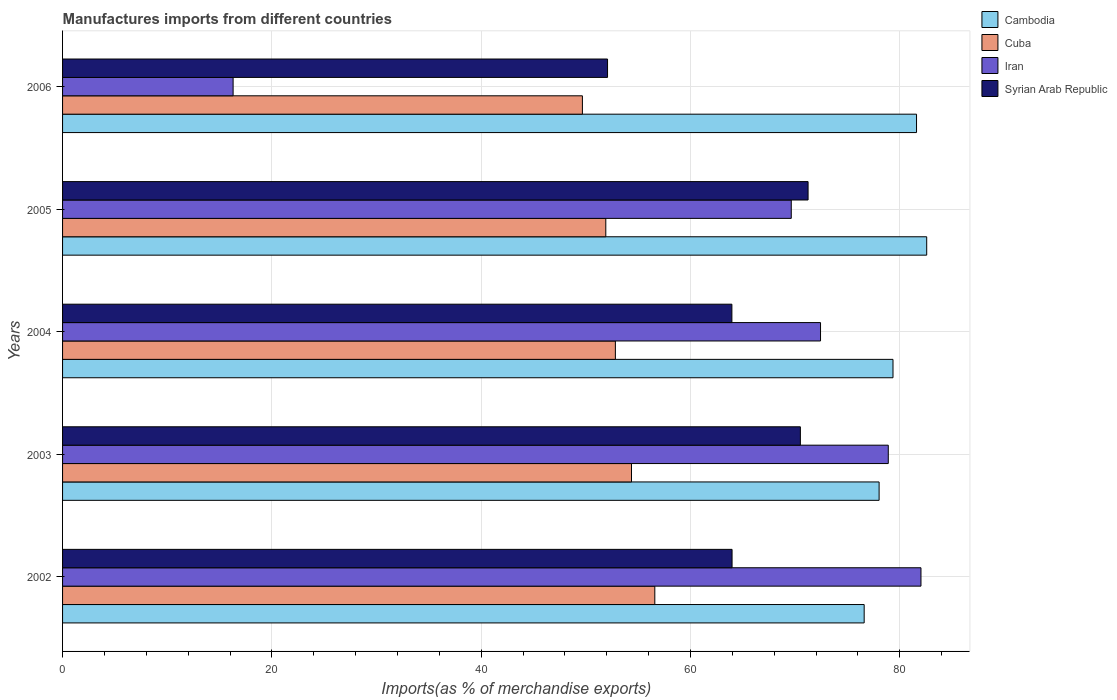How many groups of bars are there?
Offer a terse response. 5. Are the number of bars per tick equal to the number of legend labels?
Provide a short and direct response. Yes. How many bars are there on the 2nd tick from the top?
Offer a terse response. 4. How many bars are there on the 3rd tick from the bottom?
Offer a terse response. 4. What is the label of the 4th group of bars from the top?
Give a very brief answer. 2003. What is the percentage of imports to different countries in Cambodia in 2006?
Your response must be concise. 81.6. Across all years, what is the maximum percentage of imports to different countries in Cambodia?
Offer a terse response. 82.57. Across all years, what is the minimum percentage of imports to different countries in Cambodia?
Your answer should be very brief. 76.59. What is the total percentage of imports to different countries in Syrian Arab Republic in the graph?
Give a very brief answer. 321.72. What is the difference between the percentage of imports to different countries in Cuba in 2003 and that in 2004?
Your answer should be very brief. 1.54. What is the difference between the percentage of imports to different countries in Cuba in 2006 and the percentage of imports to different countries in Iran in 2005?
Provide a short and direct response. -19.96. What is the average percentage of imports to different countries in Syrian Arab Republic per year?
Your answer should be very brief. 64.34. In the year 2004, what is the difference between the percentage of imports to different countries in Syrian Arab Republic and percentage of imports to different countries in Cuba?
Provide a succinct answer. 11.13. In how many years, is the percentage of imports to different countries in Cuba greater than 52 %?
Keep it short and to the point. 3. What is the ratio of the percentage of imports to different countries in Iran in 2002 to that in 2004?
Provide a short and direct response. 1.13. What is the difference between the highest and the second highest percentage of imports to different countries in Cambodia?
Offer a very short reply. 0.97. What is the difference between the highest and the lowest percentage of imports to different countries in Iran?
Ensure brevity in your answer.  65.72. In how many years, is the percentage of imports to different countries in Syrian Arab Republic greater than the average percentage of imports to different countries in Syrian Arab Republic taken over all years?
Your response must be concise. 2. Is the sum of the percentage of imports to different countries in Cambodia in 2005 and 2006 greater than the maximum percentage of imports to different countries in Iran across all years?
Offer a very short reply. Yes. Is it the case that in every year, the sum of the percentage of imports to different countries in Iran and percentage of imports to different countries in Syrian Arab Republic is greater than the sum of percentage of imports to different countries in Cuba and percentage of imports to different countries in Cambodia?
Provide a short and direct response. No. What does the 4th bar from the top in 2006 represents?
Your response must be concise. Cambodia. What does the 4th bar from the bottom in 2003 represents?
Offer a very short reply. Syrian Arab Republic. Is it the case that in every year, the sum of the percentage of imports to different countries in Cuba and percentage of imports to different countries in Cambodia is greater than the percentage of imports to different countries in Iran?
Offer a very short reply. Yes. Are the values on the major ticks of X-axis written in scientific E-notation?
Your answer should be compact. No. Does the graph contain any zero values?
Give a very brief answer. No. Where does the legend appear in the graph?
Offer a terse response. Top right. How are the legend labels stacked?
Ensure brevity in your answer.  Vertical. What is the title of the graph?
Provide a short and direct response. Manufactures imports from different countries. What is the label or title of the X-axis?
Provide a short and direct response. Imports(as % of merchandise exports). What is the label or title of the Y-axis?
Your answer should be compact. Years. What is the Imports(as % of merchandise exports) of Cambodia in 2002?
Your answer should be very brief. 76.59. What is the Imports(as % of merchandise exports) of Cuba in 2002?
Your answer should be very brief. 56.59. What is the Imports(as % of merchandise exports) in Iran in 2002?
Provide a short and direct response. 82.02. What is the Imports(as % of merchandise exports) in Syrian Arab Republic in 2002?
Offer a terse response. 63.97. What is the Imports(as % of merchandise exports) in Cambodia in 2003?
Provide a short and direct response. 78.02. What is the Imports(as % of merchandise exports) of Cuba in 2003?
Offer a terse response. 54.36. What is the Imports(as % of merchandise exports) of Iran in 2003?
Offer a terse response. 78.9. What is the Imports(as % of merchandise exports) in Syrian Arab Republic in 2003?
Your answer should be compact. 70.5. What is the Imports(as % of merchandise exports) of Cambodia in 2004?
Offer a terse response. 79.35. What is the Imports(as % of merchandise exports) in Cuba in 2004?
Your response must be concise. 52.82. What is the Imports(as % of merchandise exports) of Iran in 2004?
Keep it short and to the point. 72.42. What is the Imports(as % of merchandise exports) of Syrian Arab Republic in 2004?
Give a very brief answer. 63.95. What is the Imports(as % of merchandise exports) of Cambodia in 2005?
Offer a very short reply. 82.57. What is the Imports(as % of merchandise exports) of Cuba in 2005?
Provide a short and direct response. 51.9. What is the Imports(as % of merchandise exports) in Iran in 2005?
Your answer should be very brief. 69.63. What is the Imports(as % of merchandise exports) of Syrian Arab Republic in 2005?
Your response must be concise. 71.23. What is the Imports(as % of merchandise exports) in Cambodia in 2006?
Offer a terse response. 81.6. What is the Imports(as % of merchandise exports) in Cuba in 2006?
Make the answer very short. 49.67. What is the Imports(as % of merchandise exports) in Iran in 2006?
Offer a very short reply. 16.3. What is the Imports(as % of merchandise exports) of Syrian Arab Republic in 2006?
Your response must be concise. 52.07. Across all years, what is the maximum Imports(as % of merchandise exports) in Cambodia?
Make the answer very short. 82.57. Across all years, what is the maximum Imports(as % of merchandise exports) of Cuba?
Offer a very short reply. 56.59. Across all years, what is the maximum Imports(as % of merchandise exports) in Iran?
Provide a short and direct response. 82.02. Across all years, what is the maximum Imports(as % of merchandise exports) of Syrian Arab Republic?
Provide a short and direct response. 71.23. Across all years, what is the minimum Imports(as % of merchandise exports) in Cambodia?
Provide a short and direct response. 76.59. Across all years, what is the minimum Imports(as % of merchandise exports) of Cuba?
Keep it short and to the point. 49.67. Across all years, what is the minimum Imports(as % of merchandise exports) of Iran?
Offer a very short reply. 16.3. Across all years, what is the minimum Imports(as % of merchandise exports) of Syrian Arab Republic?
Give a very brief answer. 52.07. What is the total Imports(as % of merchandise exports) of Cambodia in the graph?
Your answer should be very brief. 398.12. What is the total Imports(as % of merchandise exports) in Cuba in the graph?
Your response must be concise. 265.34. What is the total Imports(as % of merchandise exports) of Iran in the graph?
Keep it short and to the point. 319.26. What is the total Imports(as % of merchandise exports) in Syrian Arab Republic in the graph?
Offer a very short reply. 321.72. What is the difference between the Imports(as % of merchandise exports) in Cambodia in 2002 and that in 2003?
Your response must be concise. -1.43. What is the difference between the Imports(as % of merchandise exports) of Cuba in 2002 and that in 2003?
Your response must be concise. 2.23. What is the difference between the Imports(as % of merchandise exports) of Iran in 2002 and that in 2003?
Provide a succinct answer. 3.12. What is the difference between the Imports(as % of merchandise exports) of Syrian Arab Republic in 2002 and that in 2003?
Give a very brief answer. -6.53. What is the difference between the Imports(as % of merchandise exports) in Cambodia in 2002 and that in 2004?
Your answer should be very brief. -2.75. What is the difference between the Imports(as % of merchandise exports) in Cuba in 2002 and that in 2004?
Ensure brevity in your answer.  3.77. What is the difference between the Imports(as % of merchandise exports) of Iran in 2002 and that in 2004?
Ensure brevity in your answer.  9.6. What is the difference between the Imports(as % of merchandise exports) in Syrian Arab Republic in 2002 and that in 2004?
Your answer should be very brief. 0.02. What is the difference between the Imports(as % of merchandise exports) of Cambodia in 2002 and that in 2005?
Give a very brief answer. -5.98. What is the difference between the Imports(as % of merchandise exports) in Cuba in 2002 and that in 2005?
Your answer should be very brief. 4.68. What is the difference between the Imports(as % of merchandise exports) in Iran in 2002 and that in 2005?
Keep it short and to the point. 12.39. What is the difference between the Imports(as % of merchandise exports) of Syrian Arab Republic in 2002 and that in 2005?
Make the answer very short. -7.26. What is the difference between the Imports(as % of merchandise exports) of Cambodia in 2002 and that in 2006?
Provide a succinct answer. -5. What is the difference between the Imports(as % of merchandise exports) in Cuba in 2002 and that in 2006?
Give a very brief answer. 6.92. What is the difference between the Imports(as % of merchandise exports) in Iran in 2002 and that in 2006?
Provide a succinct answer. 65.72. What is the difference between the Imports(as % of merchandise exports) in Syrian Arab Republic in 2002 and that in 2006?
Your answer should be compact. 11.9. What is the difference between the Imports(as % of merchandise exports) in Cambodia in 2003 and that in 2004?
Ensure brevity in your answer.  -1.33. What is the difference between the Imports(as % of merchandise exports) in Cuba in 2003 and that in 2004?
Provide a short and direct response. 1.54. What is the difference between the Imports(as % of merchandise exports) of Iran in 2003 and that in 2004?
Provide a succinct answer. 6.47. What is the difference between the Imports(as % of merchandise exports) of Syrian Arab Republic in 2003 and that in 2004?
Provide a succinct answer. 6.54. What is the difference between the Imports(as % of merchandise exports) in Cambodia in 2003 and that in 2005?
Ensure brevity in your answer.  -4.55. What is the difference between the Imports(as % of merchandise exports) in Cuba in 2003 and that in 2005?
Make the answer very short. 2.46. What is the difference between the Imports(as % of merchandise exports) in Iran in 2003 and that in 2005?
Your answer should be compact. 9.27. What is the difference between the Imports(as % of merchandise exports) of Syrian Arab Republic in 2003 and that in 2005?
Offer a terse response. -0.74. What is the difference between the Imports(as % of merchandise exports) of Cambodia in 2003 and that in 2006?
Make the answer very short. -3.58. What is the difference between the Imports(as % of merchandise exports) of Cuba in 2003 and that in 2006?
Keep it short and to the point. 4.69. What is the difference between the Imports(as % of merchandise exports) in Iran in 2003 and that in 2006?
Make the answer very short. 62.6. What is the difference between the Imports(as % of merchandise exports) of Syrian Arab Republic in 2003 and that in 2006?
Provide a succinct answer. 18.43. What is the difference between the Imports(as % of merchandise exports) in Cambodia in 2004 and that in 2005?
Offer a terse response. -3.22. What is the difference between the Imports(as % of merchandise exports) in Cuba in 2004 and that in 2005?
Your answer should be very brief. 0.92. What is the difference between the Imports(as % of merchandise exports) of Iran in 2004 and that in 2005?
Provide a succinct answer. 2.8. What is the difference between the Imports(as % of merchandise exports) of Syrian Arab Republic in 2004 and that in 2005?
Offer a terse response. -7.28. What is the difference between the Imports(as % of merchandise exports) in Cambodia in 2004 and that in 2006?
Make the answer very short. -2.25. What is the difference between the Imports(as % of merchandise exports) of Cuba in 2004 and that in 2006?
Provide a short and direct response. 3.15. What is the difference between the Imports(as % of merchandise exports) in Iran in 2004 and that in 2006?
Give a very brief answer. 56.13. What is the difference between the Imports(as % of merchandise exports) of Syrian Arab Republic in 2004 and that in 2006?
Your answer should be very brief. 11.88. What is the difference between the Imports(as % of merchandise exports) in Cambodia in 2005 and that in 2006?
Your answer should be very brief. 0.97. What is the difference between the Imports(as % of merchandise exports) in Cuba in 2005 and that in 2006?
Offer a terse response. 2.23. What is the difference between the Imports(as % of merchandise exports) in Iran in 2005 and that in 2006?
Your answer should be very brief. 53.33. What is the difference between the Imports(as % of merchandise exports) of Syrian Arab Republic in 2005 and that in 2006?
Ensure brevity in your answer.  19.16. What is the difference between the Imports(as % of merchandise exports) of Cambodia in 2002 and the Imports(as % of merchandise exports) of Cuba in 2003?
Offer a very short reply. 22.23. What is the difference between the Imports(as % of merchandise exports) in Cambodia in 2002 and the Imports(as % of merchandise exports) in Iran in 2003?
Give a very brief answer. -2.3. What is the difference between the Imports(as % of merchandise exports) in Cambodia in 2002 and the Imports(as % of merchandise exports) in Syrian Arab Republic in 2003?
Ensure brevity in your answer.  6.09. What is the difference between the Imports(as % of merchandise exports) in Cuba in 2002 and the Imports(as % of merchandise exports) in Iran in 2003?
Offer a very short reply. -22.31. What is the difference between the Imports(as % of merchandise exports) of Cuba in 2002 and the Imports(as % of merchandise exports) of Syrian Arab Republic in 2003?
Offer a terse response. -13.91. What is the difference between the Imports(as % of merchandise exports) of Iran in 2002 and the Imports(as % of merchandise exports) of Syrian Arab Republic in 2003?
Provide a succinct answer. 11.52. What is the difference between the Imports(as % of merchandise exports) of Cambodia in 2002 and the Imports(as % of merchandise exports) of Cuba in 2004?
Give a very brief answer. 23.77. What is the difference between the Imports(as % of merchandise exports) in Cambodia in 2002 and the Imports(as % of merchandise exports) in Iran in 2004?
Provide a short and direct response. 4.17. What is the difference between the Imports(as % of merchandise exports) in Cambodia in 2002 and the Imports(as % of merchandise exports) in Syrian Arab Republic in 2004?
Provide a succinct answer. 12.64. What is the difference between the Imports(as % of merchandise exports) of Cuba in 2002 and the Imports(as % of merchandise exports) of Iran in 2004?
Offer a terse response. -15.83. What is the difference between the Imports(as % of merchandise exports) of Cuba in 2002 and the Imports(as % of merchandise exports) of Syrian Arab Republic in 2004?
Your answer should be very brief. -7.36. What is the difference between the Imports(as % of merchandise exports) of Iran in 2002 and the Imports(as % of merchandise exports) of Syrian Arab Republic in 2004?
Your response must be concise. 18.07. What is the difference between the Imports(as % of merchandise exports) in Cambodia in 2002 and the Imports(as % of merchandise exports) in Cuba in 2005?
Keep it short and to the point. 24.69. What is the difference between the Imports(as % of merchandise exports) in Cambodia in 2002 and the Imports(as % of merchandise exports) in Iran in 2005?
Give a very brief answer. 6.97. What is the difference between the Imports(as % of merchandise exports) in Cambodia in 2002 and the Imports(as % of merchandise exports) in Syrian Arab Republic in 2005?
Offer a very short reply. 5.36. What is the difference between the Imports(as % of merchandise exports) in Cuba in 2002 and the Imports(as % of merchandise exports) in Iran in 2005?
Your response must be concise. -13.04. What is the difference between the Imports(as % of merchandise exports) of Cuba in 2002 and the Imports(as % of merchandise exports) of Syrian Arab Republic in 2005?
Offer a very short reply. -14.64. What is the difference between the Imports(as % of merchandise exports) of Iran in 2002 and the Imports(as % of merchandise exports) of Syrian Arab Republic in 2005?
Your answer should be compact. 10.79. What is the difference between the Imports(as % of merchandise exports) of Cambodia in 2002 and the Imports(as % of merchandise exports) of Cuba in 2006?
Your answer should be compact. 26.92. What is the difference between the Imports(as % of merchandise exports) of Cambodia in 2002 and the Imports(as % of merchandise exports) of Iran in 2006?
Your answer should be very brief. 60.3. What is the difference between the Imports(as % of merchandise exports) of Cambodia in 2002 and the Imports(as % of merchandise exports) of Syrian Arab Republic in 2006?
Your answer should be compact. 24.52. What is the difference between the Imports(as % of merchandise exports) of Cuba in 2002 and the Imports(as % of merchandise exports) of Iran in 2006?
Offer a very short reply. 40.29. What is the difference between the Imports(as % of merchandise exports) of Cuba in 2002 and the Imports(as % of merchandise exports) of Syrian Arab Republic in 2006?
Provide a succinct answer. 4.52. What is the difference between the Imports(as % of merchandise exports) in Iran in 2002 and the Imports(as % of merchandise exports) in Syrian Arab Republic in 2006?
Your response must be concise. 29.95. What is the difference between the Imports(as % of merchandise exports) of Cambodia in 2003 and the Imports(as % of merchandise exports) of Cuba in 2004?
Offer a terse response. 25.2. What is the difference between the Imports(as % of merchandise exports) in Cambodia in 2003 and the Imports(as % of merchandise exports) in Iran in 2004?
Provide a succinct answer. 5.6. What is the difference between the Imports(as % of merchandise exports) in Cambodia in 2003 and the Imports(as % of merchandise exports) in Syrian Arab Republic in 2004?
Keep it short and to the point. 14.07. What is the difference between the Imports(as % of merchandise exports) in Cuba in 2003 and the Imports(as % of merchandise exports) in Iran in 2004?
Ensure brevity in your answer.  -18.06. What is the difference between the Imports(as % of merchandise exports) in Cuba in 2003 and the Imports(as % of merchandise exports) in Syrian Arab Republic in 2004?
Give a very brief answer. -9.59. What is the difference between the Imports(as % of merchandise exports) of Iran in 2003 and the Imports(as % of merchandise exports) of Syrian Arab Republic in 2004?
Your answer should be very brief. 14.94. What is the difference between the Imports(as % of merchandise exports) in Cambodia in 2003 and the Imports(as % of merchandise exports) in Cuba in 2005?
Offer a very short reply. 26.12. What is the difference between the Imports(as % of merchandise exports) in Cambodia in 2003 and the Imports(as % of merchandise exports) in Iran in 2005?
Make the answer very short. 8.39. What is the difference between the Imports(as % of merchandise exports) in Cambodia in 2003 and the Imports(as % of merchandise exports) in Syrian Arab Republic in 2005?
Provide a succinct answer. 6.79. What is the difference between the Imports(as % of merchandise exports) in Cuba in 2003 and the Imports(as % of merchandise exports) in Iran in 2005?
Your answer should be very brief. -15.27. What is the difference between the Imports(as % of merchandise exports) of Cuba in 2003 and the Imports(as % of merchandise exports) of Syrian Arab Republic in 2005?
Give a very brief answer. -16.87. What is the difference between the Imports(as % of merchandise exports) of Iran in 2003 and the Imports(as % of merchandise exports) of Syrian Arab Republic in 2005?
Your response must be concise. 7.66. What is the difference between the Imports(as % of merchandise exports) of Cambodia in 2003 and the Imports(as % of merchandise exports) of Cuba in 2006?
Your answer should be compact. 28.35. What is the difference between the Imports(as % of merchandise exports) of Cambodia in 2003 and the Imports(as % of merchandise exports) of Iran in 2006?
Give a very brief answer. 61.72. What is the difference between the Imports(as % of merchandise exports) in Cambodia in 2003 and the Imports(as % of merchandise exports) in Syrian Arab Republic in 2006?
Provide a short and direct response. 25.95. What is the difference between the Imports(as % of merchandise exports) of Cuba in 2003 and the Imports(as % of merchandise exports) of Iran in 2006?
Give a very brief answer. 38.07. What is the difference between the Imports(as % of merchandise exports) in Cuba in 2003 and the Imports(as % of merchandise exports) in Syrian Arab Republic in 2006?
Ensure brevity in your answer.  2.29. What is the difference between the Imports(as % of merchandise exports) of Iran in 2003 and the Imports(as % of merchandise exports) of Syrian Arab Republic in 2006?
Provide a short and direct response. 26.82. What is the difference between the Imports(as % of merchandise exports) of Cambodia in 2004 and the Imports(as % of merchandise exports) of Cuba in 2005?
Offer a terse response. 27.44. What is the difference between the Imports(as % of merchandise exports) in Cambodia in 2004 and the Imports(as % of merchandise exports) in Iran in 2005?
Offer a terse response. 9.72. What is the difference between the Imports(as % of merchandise exports) of Cambodia in 2004 and the Imports(as % of merchandise exports) of Syrian Arab Republic in 2005?
Offer a very short reply. 8.11. What is the difference between the Imports(as % of merchandise exports) of Cuba in 2004 and the Imports(as % of merchandise exports) of Iran in 2005?
Offer a terse response. -16.81. What is the difference between the Imports(as % of merchandise exports) of Cuba in 2004 and the Imports(as % of merchandise exports) of Syrian Arab Republic in 2005?
Make the answer very short. -18.41. What is the difference between the Imports(as % of merchandise exports) of Iran in 2004 and the Imports(as % of merchandise exports) of Syrian Arab Republic in 2005?
Keep it short and to the point. 1.19. What is the difference between the Imports(as % of merchandise exports) in Cambodia in 2004 and the Imports(as % of merchandise exports) in Cuba in 2006?
Give a very brief answer. 29.68. What is the difference between the Imports(as % of merchandise exports) in Cambodia in 2004 and the Imports(as % of merchandise exports) in Iran in 2006?
Your answer should be compact. 63.05. What is the difference between the Imports(as % of merchandise exports) in Cambodia in 2004 and the Imports(as % of merchandise exports) in Syrian Arab Republic in 2006?
Give a very brief answer. 27.27. What is the difference between the Imports(as % of merchandise exports) in Cuba in 2004 and the Imports(as % of merchandise exports) in Iran in 2006?
Offer a terse response. 36.52. What is the difference between the Imports(as % of merchandise exports) of Cuba in 2004 and the Imports(as % of merchandise exports) of Syrian Arab Republic in 2006?
Give a very brief answer. 0.75. What is the difference between the Imports(as % of merchandise exports) of Iran in 2004 and the Imports(as % of merchandise exports) of Syrian Arab Republic in 2006?
Offer a very short reply. 20.35. What is the difference between the Imports(as % of merchandise exports) of Cambodia in 2005 and the Imports(as % of merchandise exports) of Cuba in 2006?
Keep it short and to the point. 32.9. What is the difference between the Imports(as % of merchandise exports) of Cambodia in 2005 and the Imports(as % of merchandise exports) of Iran in 2006?
Provide a succinct answer. 66.27. What is the difference between the Imports(as % of merchandise exports) in Cambodia in 2005 and the Imports(as % of merchandise exports) in Syrian Arab Republic in 2006?
Keep it short and to the point. 30.5. What is the difference between the Imports(as % of merchandise exports) of Cuba in 2005 and the Imports(as % of merchandise exports) of Iran in 2006?
Provide a succinct answer. 35.61. What is the difference between the Imports(as % of merchandise exports) in Cuba in 2005 and the Imports(as % of merchandise exports) in Syrian Arab Republic in 2006?
Your answer should be compact. -0.17. What is the difference between the Imports(as % of merchandise exports) of Iran in 2005 and the Imports(as % of merchandise exports) of Syrian Arab Republic in 2006?
Ensure brevity in your answer.  17.55. What is the average Imports(as % of merchandise exports) in Cambodia per year?
Offer a terse response. 79.62. What is the average Imports(as % of merchandise exports) of Cuba per year?
Keep it short and to the point. 53.07. What is the average Imports(as % of merchandise exports) in Iran per year?
Provide a short and direct response. 63.85. What is the average Imports(as % of merchandise exports) in Syrian Arab Republic per year?
Give a very brief answer. 64.34. In the year 2002, what is the difference between the Imports(as % of merchandise exports) of Cambodia and Imports(as % of merchandise exports) of Cuba?
Offer a very short reply. 20. In the year 2002, what is the difference between the Imports(as % of merchandise exports) in Cambodia and Imports(as % of merchandise exports) in Iran?
Offer a terse response. -5.43. In the year 2002, what is the difference between the Imports(as % of merchandise exports) of Cambodia and Imports(as % of merchandise exports) of Syrian Arab Republic?
Offer a very short reply. 12.62. In the year 2002, what is the difference between the Imports(as % of merchandise exports) of Cuba and Imports(as % of merchandise exports) of Iran?
Make the answer very short. -25.43. In the year 2002, what is the difference between the Imports(as % of merchandise exports) in Cuba and Imports(as % of merchandise exports) in Syrian Arab Republic?
Provide a succinct answer. -7.38. In the year 2002, what is the difference between the Imports(as % of merchandise exports) of Iran and Imports(as % of merchandise exports) of Syrian Arab Republic?
Keep it short and to the point. 18.05. In the year 2003, what is the difference between the Imports(as % of merchandise exports) of Cambodia and Imports(as % of merchandise exports) of Cuba?
Your answer should be compact. 23.66. In the year 2003, what is the difference between the Imports(as % of merchandise exports) in Cambodia and Imports(as % of merchandise exports) in Iran?
Your answer should be very brief. -0.88. In the year 2003, what is the difference between the Imports(as % of merchandise exports) in Cambodia and Imports(as % of merchandise exports) in Syrian Arab Republic?
Give a very brief answer. 7.52. In the year 2003, what is the difference between the Imports(as % of merchandise exports) of Cuba and Imports(as % of merchandise exports) of Iran?
Ensure brevity in your answer.  -24.54. In the year 2003, what is the difference between the Imports(as % of merchandise exports) of Cuba and Imports(as % of merchandise exports) of Syrian Arab Republic?
Give a very brief answer. -16.14. In the year 2003, what is the difference between the Imports(as % of merchandise exports) in Iran and Imports(as % of merchandise exports) in Syrian Arab Republic?
Your answer should be very brief. 8.4. In the year 2004, what is the difference between the Imports(as % of merchandise exports) of Cambodia and Imports(as % of merchandise exports) of Cuba?
Give a very brief answer. 26.53. In the year 2004, what is the difference between the Imports(as % of merchandise exports) in Cambodia and Imports(as % of merchandise exports) in Iran?
Your answer should be compact. 6.92. In the year 2004, what is the difference between the Imports(as % of merchandise exports) of Cambodia and Imports(as % of merchandise exports) of Syrian Arab Republic?
Your answer should be very brief. 15.39. In the year 2004, what is the difference between the Imports(as % of merchandise exports) of Cuba and Imports(as % of merchandise exports) of Iran?
Make the answer very short. -19.6. In the year 2004, what is the difference between the Imports(as % of merchandise exports) in Cuba and Imports(as % of merchandise exports) in Syrian Arab Republic?
Your answer should be compact. -11.13. In the year 2004, what is the difference between the Imports(as % of merchandise exports) in Iran and Imports(as % of merchandise exports) in Syrian Arab Republic?
Offer a very short reply. 8.47. In the year 2005, what is the difference between the Imports(as % of merchandise exports) in Cambodia and Imports(as % of merchandise exports) in Cuba?
Offer a terse response. 30.66. In the year 2005, what is the difference between the Imports(as % of merchandise exports) of Cambodia and Imports(as % of merchandise exports) of Iran?
Make the answer very short. 12.94. In the year 2005, what is the difference between the Imports(as % of merchandise exports) of Cambodia and Imports(as % of merchandise exports) of Syrian Arab Republic?
Ensure brevity in your answer.  11.33. In the year 2005, what is the difference between the Imports(as % of merchandise exports) in Cuba and Imports(as % of merchandise exports) in Iran?
Provide a succinct answer. -17.72. In the year 2005, what is the difference between the Imports(as % of merchandise exports) in Cuba and Imports(as % of merchandise exports) in Syrian Arab Republic?
Offer a terse response. -19.33. In the year 2005, what is the difference between the Imports(as % of merchandise exports) in Iran and Imports(as % of merchandise exports) in Syrian Arab Republic?
Your answer should be compact. -1.61. In the year 2006, what is the difference between the Imports(as % of merchandise exports) in Cambodia and Imports(as % of merchandise exports) in Cuba?
Provide a short and direct response. 31.92. In the year 2006, what is the difference between the Imports(as % of merchandise exports) in Cambodia and Imports(as % of merchandise exports) in Iran?
Make the answer very short. 65.3. In the year 2006, what is the difference between the Imports(as % of merchandise exports) in Cambodia and Imports(as % of merchandise exports) in Syrian Arab Republic?
Your answer should be compact. 29.52. In the year 2006, what is the difference between the Imports(as % of merchandise exports) of Cuba and Imports(as % of merchandise exports) of Iran?
Ensure brevity in your answer.  33.38. In the year 2006, what is the difference between the Imports(as % of merchandise exports) of Cuba and Imports(as % of merchandise exports) of Syrian Arab Republic?
Keep it short and to the point. -2.4. In the year 2006, what is the difference between the Imports(as % of merchandise exports) in Iran and Imports(as % of merchandise exports) in Syrian Arab Republic?
Provide a short and direct response. -35.78. What is the ratio of the Imports(as % of merchandise exports) of Cambodia in 2002 to that in 2003?
Ensure brevity in your answer.  0.98. What is the ratio of the Imports(as % of merchandise exports) of Cuba in 2002 to that in 2003?
Provide a short and direct response. 1.04. What is the ratio of the Imports(as % of merchandise exports) of Iran in 2002 to that in 2003?
Make the answer very short. 1.04. What is the ratio of the Imports(as % of merchandise exports) of Syrian Arab Republic in 2002 to that in 2003?
Keep it short and to the point. 0.91. What is the ratio of the Imports(as % of merchandise exports) in Cambodia in 2002 to that in 2004?
Offer a very short reply. 0.97. What is the ratio of the Imports(as % of merchandise exports) in Cuba in 2002 to that in 2004?
Make the answer very short. 1.07. What is the ratio of the Imports(as % of merchandise exports) in Iran in 2002 to that in 2004?
Provide a succinct answer. 1.13. What is the ratio of the Imports(as % of merchandise exports) in Syrian Arab Republic in 2002 to that in 2004?
Your answer should be compact. 1. What is the ratio of the Imports(as % of merchandise exports) in Cambodia in 2002 to that in 2005?
Ensure brevity in your answer.  0.93. What is the ratio of the Imports(as % of merchandise exports) of Cuba in 2002 to that in 2005?
Your answer should be very brief. 1.09. What is the ratio of the Imports(as % of merchandise exports) in Iran in 2002 to that in 2005?
Your answer should be compact. 1.18. What is the ratio of the Imports(as % of merchandise exports) of Syrian Arab Republic in 2002 to that in 2005?
Your response must be concise. 0.9. What is the ratio of the Imports(as % of merchandise exports) of Cambodia in 2002 to that in 2006?
Offer a terse response. 0.94. What is the ratio of the Imports(as % of merchandise exports) of Cuba in 2002 to that in 2006?
Offer a very short reply. 1.14. What is the ratio of the Imports(as % of merchandise exports) of Iran in 2002 to that in 2006?
Your answer should be compact. 5.03. What is the ratio of the Imports(as % of merchandise exports) of Syrian Arab Republic in 2002 to that in 2006?
Provide a short and direct response. 1.23. What is the ratio of the Imports(as % of merchandise exports) in Cambodia in 2003 to that in 2004?
Keep it short and to the point. 0.98. What is the ratio of the Imports(as % of merchandise exports) of Cuba in 2003 to that in 2004?
Keep it short and to the point. 1.03. What is the ratio of the Imports(as % of merchandise exports) in Iran in 2003 to that in 2004?
Your response must be concise. 1.09. What is the ratio of the Imports(as % of merchandise exports) of Syrian Arab Republic in 2003 to that in 2004?
Your answer should be compact. 1.1. What is the ratio of the Imports(as % of merchandise exports) in Cambodia in 2003 to that in 2005?
Provide a succinct answer. 0.94. What is the ratio of the Imports(as % of merchandise exports) in Cuba in 2003 to that in 2005?
Ensure brevity in your answer.  1.05. What is the ratio of the Imports(as % of merchandise exports) of Iran in 2003 to that in 2005?
Your answer should be compact. 1.13. What is the ratio of the Imports(as % of merchandise exports) in Cambodia in 2003 to that in 2006?
Offer a very short reply. 0.96. What is the ratio of the Imports(as % of merchandise exports) in Cuba in 2003 to that in 2006?
Ensure brevity in your answer.  1.09. What is the ratio of the Imports(as % of merchandise exports) in Iran in 2003 to that in 2006?
Offer a very short reply. 4.84. What is the ratio of the Imports(as % of merchandise exports) in Syrian Arab Republic in 2003 to that in 2006?
Provide a short and direct response. 1.35. What is the ratio of the Imports(as % of merchandise exports) in Cuba in 2004 to that in 2005?
Offer a terse response. 1.02. What is the ratio of the Imports(as % of merchandise exports) in Iran in 2004 to that in 2005?
Make the answer very short. 1.04. What is the ratio of the Imports(as % of merchandise exports) of Syrian Arab Republic in 2004 to that in 2005?
Ensure brevity in your answer.  0.9. What is the ratio of the Imports(as % of merchandise exports) of Cambodia in 2004 to that in 2006?
Make the answer very short. 0.97. What is the ratio of the Imports(as % of merchandise exports) in Cuba in 2004 to that in 2006?
Your answer should be very brief. 1.06. What is the ratio of the Imports(as % of merchandise exports) of Iran in 2004 to that in 2006?
Your answer should be very brief. 4.44. What is the ratio of the Imports(as % of merchandise exports) of Syrian Arab Republic in 2004 to that in 2006?
Make the answer very short. 1.23. What is the ratio of the Imports(as % of merchandise exports) of Cambodia in 2005 to that in 2006?
Provide a succinct answer. 1.01. What is the ratio of the Imports(as % of merchandise exports) of Cuba in 2005 to that in 2006?
Ensure brevity in your answer.  1.04. What is the ratio of the Imports(as % of merchandise exports) of Iran in 2005 to that in 2006?
Your answer should be very brief. 4.27. What is the ratio of the Imports(as % of merchandise exports) in Syrian Arab Republic in 2005 to that in 2006?
Make the answer very short. 1.37. What is the difference between the highest and the second highest Imports(as % of merchandise exports) of Cambodia?
Offer a very short reply. 0.97. What is the difference between the highest and the second highest Imports(as % of merchandise exports) in Cuba?
Provide a succinct answer. 2.23. What is the difference between the highest and the second highest Imports(as % of merchandise exports) in Iran?
Offer a very short reply. 3.12. What is the difference between the highest and the second highest Imports(as % of merchandise exports) in Syrian Arab Republic?
Your answer should be very brief. 0.74. What is the difference between the highest and the lowest Imports(as % of merchandise exports) in Cambodia?
Provide a short and direct response. 5.98. What is the difference between the highest and the lowest Imports(as % of merchandise exports) in Cuba?
Make the answer very short. 6.92. What is the difference between the highest and the lowest Imports(as % of merchandise exports) in Iran?
Provide a short and direct response. 65.72. What is the difference between the highest and the lowest Imports(as % of merchandise exports) in Syrian Arab Republic?
Keep it short and to the point. 19.16. 